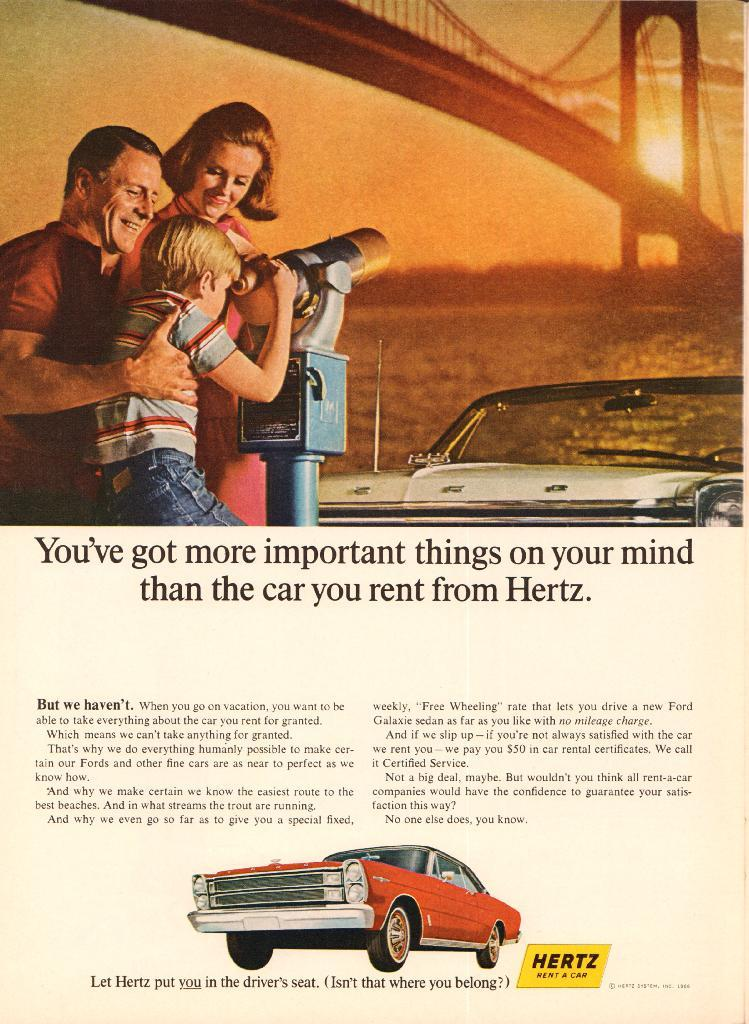What type of visual representation is the image? The image is a poster. Who or what can be seen in the image? There are people in the image. What object with a rod is present in the image? There is a binocular with a rod in the image. What mode of transportation is visible in the image? There is a vehicle and a car in the image. What natural element is present in the image? Water is visible in the image. What man-made structure is present in the image? There is a bridge in the image. What part of the natural environment is visible in the image? The sky is visible in the image, and the sun is observable in the sky. What type of text is present in the image? There is some text in the image. What symbol or branding is present in the image? There is a logo in the image. What type of rice can be seen growing near the bridge in the image? There is no rice present in the image, and rice is not a natural element that would typically grow near a bridge. 